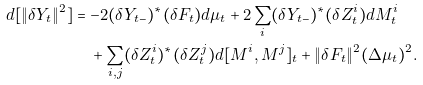<formula> <loc_0><loc_0><loc_500><loc_500>d [ \| \delta Y _ { t } \| ^ { 2 } ] & = - 2 ( \delta Y _ { t - } ) ^ { * } ( \delta F _ { t } ) d \mu _ { t } + 2 \sum _ { i } ( \delta Y _ { t - } ) ^ { * } ( \delta Z _ { t } ^ { i } ) d M ^ { i } _ { t } \\ & \quad + \sum _ { i , j } ( \delta Z _ { t } ^ { i } ) ^ { * } ( \delta Z _ { t } ^ { j } ) d [ M ^ { i } , M ^ { j } ] _ { t } + \| \delta F _ { t } \| ^ { 2 } ( \Delta \mu _ { t } ) ^ { 2 } .</formula> 